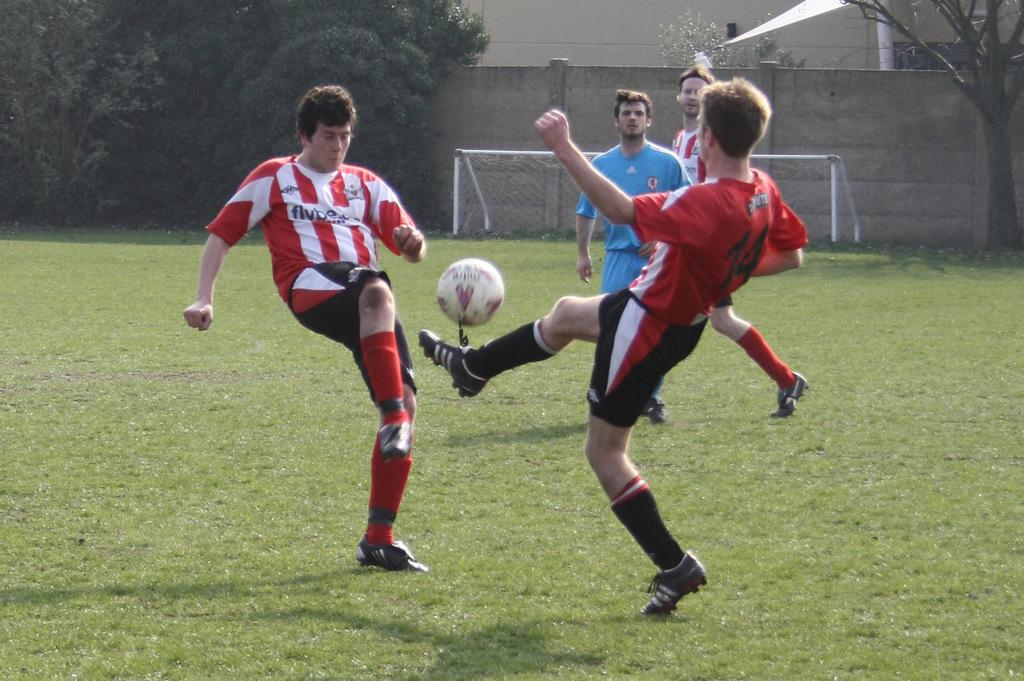How many players are involved in the activity shown in the image? There are two players in the image. What sport are the players engaged in? The players are kicking a football, which indicates they are playing soccer. Where are the players playing? The players are playing on the ground. What can be seen in the background of the image? There is a goal post, a wall, and a tree in the background of the image. What type of plane can be seen flying over the players in the image? There is no plane visible in the image; it only shows two players kicking a football on the ground. How many quinces are present on the field in the image? There are no quinces present in the image; it only shows a football being kicked by two players. 